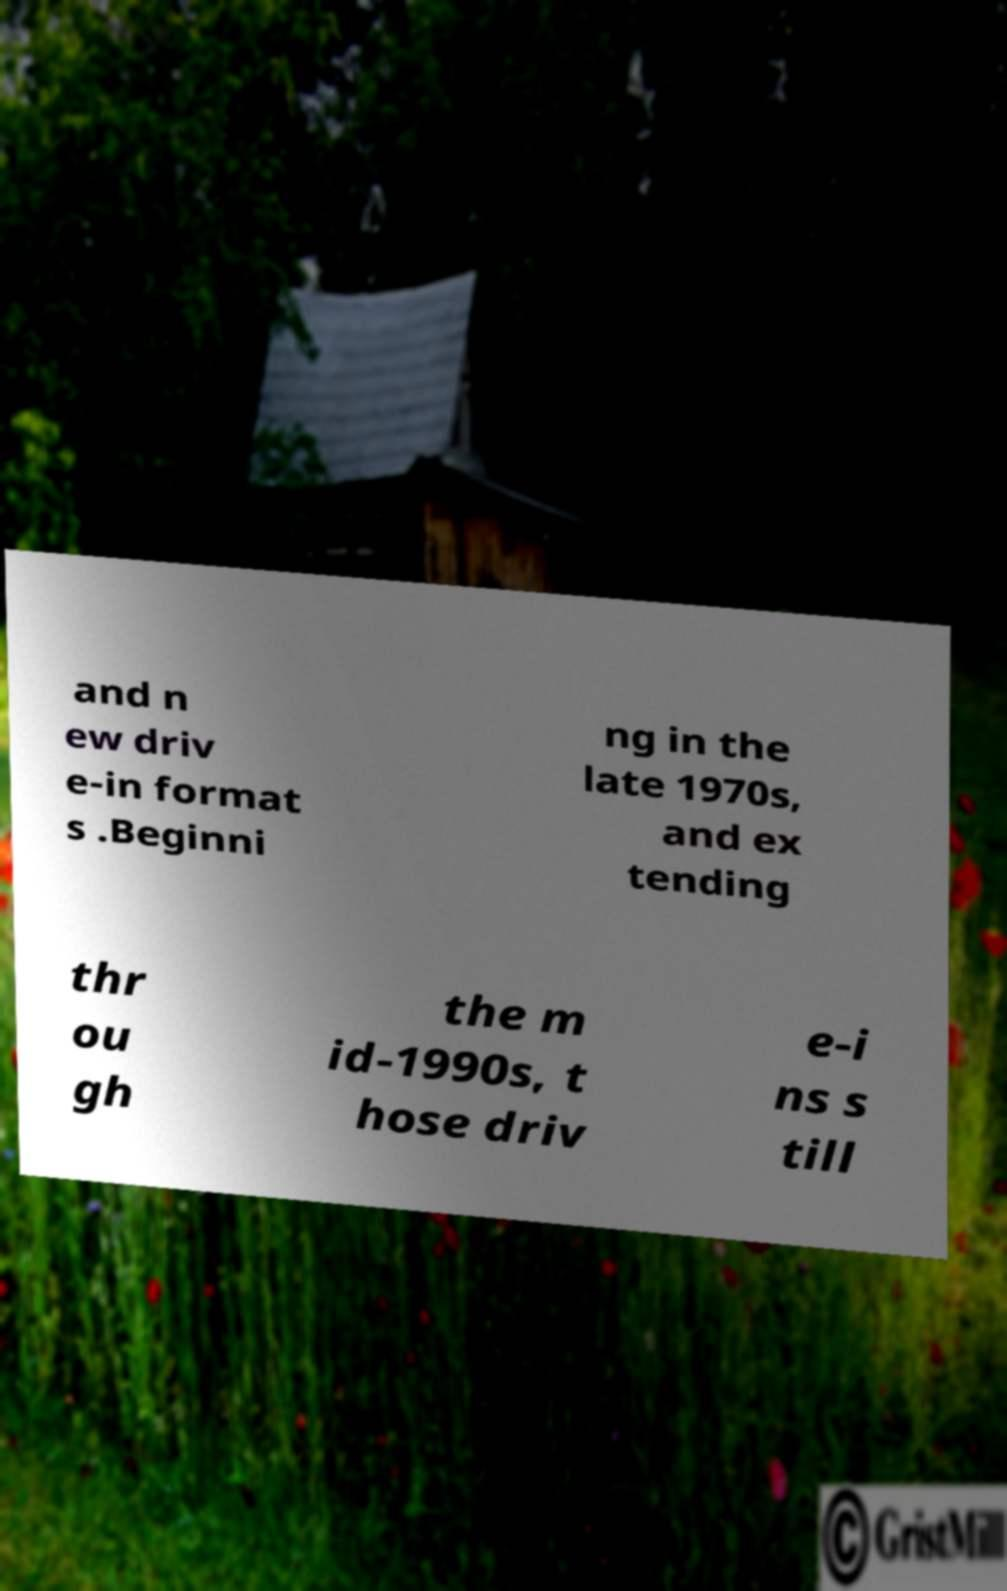Can you read and provide the text displayed in the image?This photo seems to have some interesting text. Can you extract and type it out for me? and n ew driv e-in format s .Beginni ng in the late 1970s, and ex tending thr ou gh the m id-1990s, t hose driv e-i ns s till 